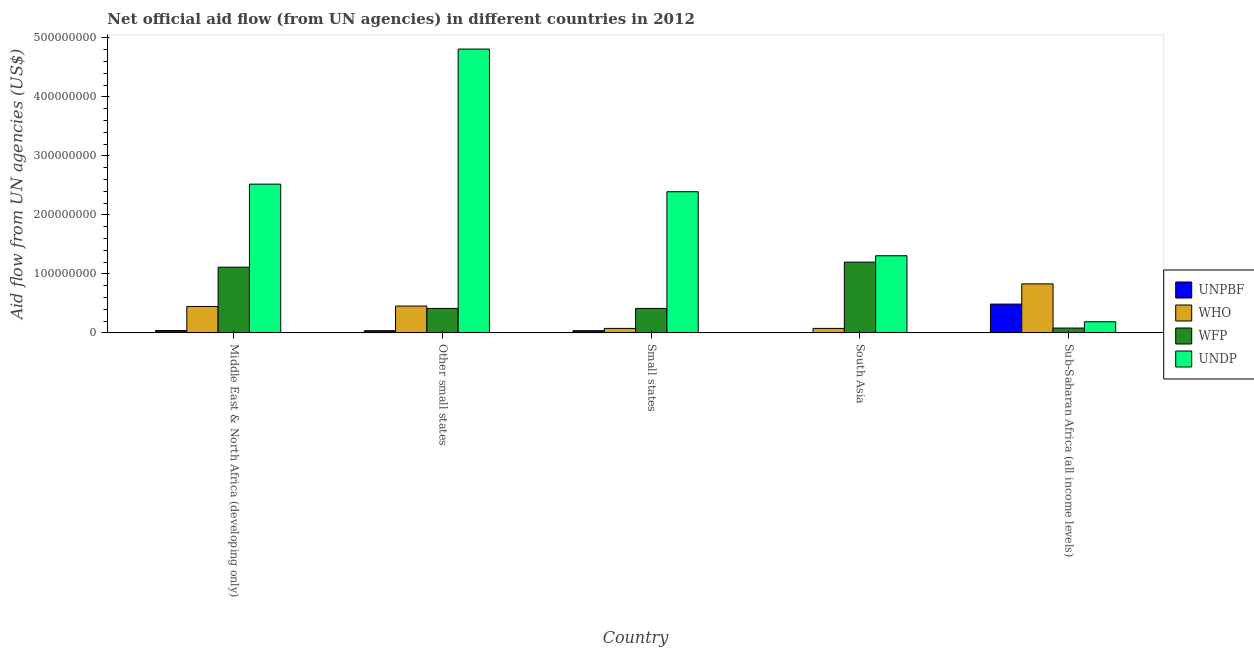How many different coloured bars are there?
Keep it short and to the point. 4. What is the label of the 2nd group of bars from the left?
Your answer should be compact. Other small states. What is the amount of aid given by unpbf in South Asia?
Ensure brevity in your answer.  2.70e+05. Across all countries, what is the maximum amount of aid given by unpbf?
Make the answer very short. 4.89e+07. Across all countries, what is the minimum amount of aid given by unpbf?
Your response must be concise. 2.70e+05. In which country was the amount of aid given by undp maximum?
Give a very brief answer. Other small states. In which country was the amount of aid given by undp minimum?
Your answer should be compact. Sub-Saharan Africa (all income levels). What is the total amount of aid given by who in the graph?
Your answer should be compact. 1.89e+08. What is the difference between the amount of aid given by unpbf in Middle East & North Africa (developing only) and that in Sub-Saharan Africa (all income levels)?
Provide a short and direct response. -4.48e+07. What is the difference between the amount of aid given by wfp in Sub-Saharan Africa (all income levels) and the amount of aid given by unpbf in Small states?
Your answer should be compact. 4.46e+06. What is the average amount of aid given by wfp per country?
Your answer should be compact. 6.46e+07. What is the difference between the amount of aid given by undp and amount of aid given by wfp in Other small states?
Your answer should be compact. 4.40e+08. In how many countries, is the amount of aid given by wfp greater than 320000000 US$?
Offer a terse response. 0. What is the ratio of the amount of aid given by who in Other small states to that in Sub-Saharan Africa (all income levels)?
Provide a succinct answer. 0.55. Is the amount of aid given by undp in Small states less than that in Sub-Saharan Africa (all income levels)?
Provide a short and direct response. No. What is the difference between the highest and the second highest amount of aid given by unpbf?
Offer a terse response. 4.48e+07. What is the difference between the highest and the lowest amount of aid given by unpbf?
Provide a short and direct response. 4.86e+07. In how many countries, is the amount of aid given by unpbf greater than the average amount of aid given by unpbf taken over all countries?
Provide a succinct answer. 1. Is the sum of the amount of aid given by who in Small states and South Asia greater than the maximum amount of aid given by wfp across all countries?
Your response must be concise. No. What does the 2nd bar from the left in Other small states represents?
Give a very brief answer. WHO. What does the 2nd bar from the right in Sub-Saharan Africa (all income levels) represents?
Keep it short and to the point. WFP. Is it the case that in every country, the sum of the amount of aid given by unpbf and amount of aid given by who is greater than the amount of aid given by wfp?
Provide a succinct answer. No. Are all the bars in the graph horizontal?
Your answer should be very brief. No. How many countries are there in the graph?
Offer a very short reply. 5. Does the graph contain any zero values?
Your answer should be compact. No. Does the graph contain grids?
Give a very brief answer. No. How many legend labels are there?
Ensure brevity in your answer.  4. What is the title of the graph?
Provide a short and direct response. Net official aid flow (from UN agencies) in different countries in 2012. Does "UNDP" appear as one of the legend labels in the graph?
Offer a very short reply. Yes. What is the label or title of the Y-axis?
Offer a very short reply. Aid flow from UN agencies (US$). What is the Aid flow from UN agencies (US$) of UNPBF in Middle East & North Africa (developing only)?
Give a very brief answer. 4.11e+06. What is the Aid flow from UN agencies (US$) of WHO in Middle East & North Africa (developing only)?
Your answer should be very brief. 4.49e+07. What is the Aid flow from UN agencies (US$) in WFP in Middle East & North Africa (developing only)?
Your answer should be compact. 1.11e+08. What is the Aid flow from UN agencies (US$) of UNDP in Middle East & North Africa (developing only)?
Provide a short and direct response. 2.52e+08. What is the Aid flow from UN agencies (US$) of UNPBF in Other small states?
Give a very brief answer. 3.82e+06. What is the Aid flow from UN agencies (US$) of WHO in Other small states?
Provide a succinct answer. 4.56e+07. What is the Aid flow from UN agencies (US$) of WFP in Other small states?
Make the answer very short. 4.16e+07. What is the Aid flow from UN agencies (US$) in UNDP in Other small states?
Your answer should be compact. 4.81e+08. What is the Aid flow from UN agencies (US$) of UNPBF in Small states?
Offer a very short reply. 3.82e+06. What is the Aid flow from UN agencies (US$) in WHO in Small states?
Your response must be concise. 7.70e+06. What is the Aid flow from UN agencies (US$) in WFP in Small states?
Keep it short and to the point. 4.16e+07. What is the Aid flow from UN agencies (US$) of UNDP in Small states?
Provide a short and direct response. 2.39e+08. What is the Aid flow from UN agencies (US$) in UNPBF in South Asia?
Your response must be concise. 2.70e+05. What is the Aid flow from UN agencies (US$) in WHO in South Asia?
Make the answer very short. 7.70e+06. What is the Aid flow from UN agencies (US$) in WFP in South Asia?
Your answer should be very brief. 1.20e+08. What is the Aid flow from UN agencies (US$) of UNDP in South Asia?
Your answer should be very brief. 1.31e+08. What is the Aid flow from UN agencies (US$) in UNPBF in Sub-Saharan Africa (all income levels)?
Your response must be concise. 4.89e+07. What is the Aid flow from UN agencies (US$) in WHO in Sub-Saharan Africa (all income levels)?
Keep it short and to the point. 8.32e+07. What is the Aid flow from UN agencies (US$) in WFP in Sub-Saharan Africa (all income levels)?
Your answer should be very brief. 8.28e+06. What is the Aid flow from UN agencies (US$) of UNDP in Sub-Saharan Africa (all income levels)?
Ensure brevity in your answer.  1.90e+07. Across all countries, what is the maximum Aid flow from UN agencies (US$) of UNPBF?
Keep it short and to the point. 4.89e+07. Across all countries, what is the maximum Aid flow from UN agencies (US$) of WHO?
Keep it short and to the point. 8.32e+07. Across all countries, what is the maximum Aid flow from UN agencies (US$) in WFP?
Give a very brief answer. 1.20e+08. Across all countries, what is the maximum Aid flow from UN agencies (US$) of UNDP?
Provide a short and direct response. 4.81e+08. Across all countries, what is the minimum Aid flow from UN agencies (US$) of UNPBF?
Make the answer very short. 2.70e+05. Across all countries, what is the minimum Aid flow from UN agencies (US$) in WHO?
Your answer should be very brief. 7.70e+06. Across all countries, what is the minimum Aid flow from UN agencies (US$) of WFP?
Provide a short and direct response. 8.28e+06. Across all countries, what is the minimum Aid flow from UN agencies (US$) of UNDP?
Offer a very short reply. 1.90e+07. What is the total Aid flow from UN agencies (US$) of UNPBF in the graph?
Keep it short and to the point. 6.09e+07. What is the total Aid flow from UN agencies (US$) in WHO in the graph?
Offer a terse response. 1.89e+08. What is the total Aid flow from UN agencies (US$) in WFP in the graph?
Keep it short and to the point. 3.23e+08. What is the total Aid flow from UN agencies (US$) in UNDP in the graph?
Offer a terse response. 1.12e+09. What is the difference between the Aid flow from UN agencies (US$) of WHO in Middle East & North Africa (developing only) and that in Other small states?
Keep it short and to the point. -7.30e+05. What is the difference between the Aid flow from UN agencies (US$) in WFP in Middle East & North Africa (developing only) and that in Other small states?
Your response must be concise. 6.99e+07. What is the difference between the Aid flow from UN agencies (US$) in UNDP in Middle East & North Africa (developing only) and that in Other small states?
Offer a terse response. -2.29e+08. What is the difference between the Aid flow from UN agencies (US$) in UNPBF in Middle East & North Africa (developing only) and that in Small states?
Provide a short and direct response. 2.90e+05. What is the difference between the Aid flow from UN agencies (US$) in WHO in Middle East & North Africa (developing only) and that in Small states?
Provide a short and direct response. 3.72e+07. What is the difference between the Aid flow from UN agencies (US$) in WFP in Middle East & North Africa (developing only) and that in Small states?
Give a very brief answer. 6.99e+07. What is the difference between the Aid flow from UN agencies (US$) of UNDP in Middle East & North Africa (developing only) and that in Small states?
Provide a short and direct response. 1.29e+07. What is the difference between the Aid flow from UN agencies (US$) of UNPBF in Middle East & North Africa (developing only) and that in South Asia?
Your response must be concise. 3.84e+06. What is the difference between the Aid flow from UN agencies (US$) in WHO in Middle East & North Africa (developing only) and that in South Asia?
Make the answer very short. 3.72e+07. What is the difference between the Aid flow from UN agencies (US$) of WFP in Middle East & North Africa (developing only) and that in South Asia?
Keep it short and to the point. -8.57e+06. What is the difference between the Aid flow from UN agencies (US$) in UNDP in Middle East & North Africa (developing only) and that in South Asia?
Offer a very short reply. 1.21e+08. What is the difference between the Aid flow from UN agencies (US$) of UNPBF in Middle East & North Africa (developing only) and that in Sub-Saharan Africa (all income levels)?
Your response must be concise. -4.48e+07. What is the difference between the Aid flow from UN agencies (US$) in WHO in Middle East & North Africa (developing only) and that in Sub-Saharan Africa (all income levels)?
Your response must be concise. -3.83e+07. What is the difference between the Aid flow from UN agencies (US$) in WFP in Middle East & North Africa (developing only) and that in Sub-Saharan Africa (all income levels)?
Your response must be concise. 1.03e+08. What is the difference between the Aid flow from UN agencies (US$) in UNDP in Middle East & North Africa (developing only) and that in Sub-Saharan Africa (all income levels)?
Give a very brief answer. 2.33e+08. What is the difference between the Aid flow from UN agencies (US$) of UNPBF in Other small states and that in Small states?
Provide a succinct answer. 0. What is the difference between the Aid flow from UN agencies (US$) in WHO in Other small states and that in Small states?
Your response must be concise. 3.79e+07. What is the difference between the Aid flow from UN agencies (US$) in WFP in Other small states and that in Small states?
Ensure brevity in your answer.  0. What is the difference between the Aid flow from UN agencies (US$) of UNDP in Other small states and that in Small states?
Your response must be concise. 2.42e+08. What is the difference between the Aid flow from UN agencies (US$) of UNPBF in Other small states and that in South Asia?
Offer a terse response. 3.55e+06. What is the difference between the Aid flow from UN agencies (US$) of WHO in Other small states and that in South Asia?
Provide a short and direct response. 3.79e+07. What is the difference between the Aid flow from UN agencies (US$) of WFP in Other small states and that in South Asia?
Provide a short and direct response. -7.85e+07. What is the difference between the Aid flow from UN agencies (US$) in UNDP in Other small states and that in South Asia?
Provide a succinct answer. 3.50e+08. What is the difference between the Aid flow from UN agencies (US$) of UNPBF in Other small states and that in Sub-Saharan Africa (all income levels)?
Provide a short and direct response. -4.51e+07. What is the difference between the Aid flow from UN agencies (US$) of WHO in Other small states and that in Sub-Saharan Africa (all income levels)?
Your answer should be compact. -3.76e+07. What is the difference between the Aid flow from UN agencies (US$) of WFP in Other small states and that in Sub-Saharan Africa (all income levels)?
Your answer should be compact. 3.33e+07. What is the difference between the Aid flow from UN agencies (US$) in UNDP in Other small states and that in Sub-Saharan Africa (all income levels)?
Your response must be concise. 4.62e+08. What is the difference between the Aid flow from UN agencies (US$) of UNPBF in Small states and that in South Asia?
Make the answer very short. 3.55e+06. What is the difference between the Aid flow from UN agencies (US$) in WFP in Small states and that in South Asia?
Offer a terse response. -7.85e+07. What is the difference between the Aid flow from UN agencies (US$) of UNDP in Small states and that in South Asia?
Provide a short and direct response. 1.09e+08. What is the difference between the Aid flow from UN agencies (US$) of UNPBF in Small states and that in Sub-Saharan Africa (all income levels)?
Your answer should be very brief. -4.51e+07. What is the difference between the Aid flow from UN agencies (US$) in WHO in Small states and that in Sub-Saharan Africa (all income levels)?
Provide a short and direct response. -7.55e+07. What is the difference between the Aid flow from UN agencies (US$) in WFP in Small states and that in Sub-Saharan Africa (all income levels)?
Provide a short and direct response. 3.33e+07. What is the difference between the Aid flow from UN agencies (US$) of UNDP in Small states and that in Sub-Saharan Africa (all income levels)?
Give a very brief answer. 2.20e+08. What is the difference between the Aid flow from UN agencies (US$) of UNPBF in South Asia and that in Sub-Saharan Africa (all income levels)?
Make the answer very short. -4.86e+07. What is the difference between the Aid flow from UN agencies (US$) in WHO in South Asia and that in Sub-Saharan Africa (all income levels)?
Your response must be concise. -7.55e+07. What is the difference between the Aid flow from UN agencies (US$) in WFP in South Asia and that in Sub-Saharan Africa (all income levels)?
Your answer should be very brief. 1.12e+08. What is the difference between the Aid flow from UN agencies (US$) of UNDP in South Asia and that in Sub-Saharan Africa (all income levels)?
Your answer should be compact. 1.12e+08. What is the difference between the Aid flow from UN agencies (US$) in UNPBF in Middle East & North Africa (developing only) and the Aid flow from UN agencies (US$) in WHO in Other small states?
Your answer should be very brief. -4.15e+07. What is the difference between the Aid flow from UN agencies (US$) in UNPBF in Middle East & North Africa (developing only) and the Aid flow from UN agencies (US$) in WFP in Other small states?
Provide a short and direct response. -3.75e+07. What is the difference between the Aid flow from UN agencies (US$) in UNPBF in Middle East & North Africa (developing only) and the Aid flow from UN agencies (US$) in UNDP in Other small states?
Give a very brief answer. -4.77e+08. What is the difference between the Aid flow from UN agencies (US$) of WHO in Middle East & North Africa (developing only) and the Aid flow from UN agencies (US$) of WFP in Other small states?
Give a very brief answer. 3.30e+06. What is the difference between the Aid flow from UN agencies (US$) in WHO in Middle East & North Africa (developing only) and the Aid flow from UN agencies (US$) in UNDP in Other small states?
Make the answer very short. -4.36e+08. What is the difference between the Aid flow from UN agencies (US$) in WFP in Middle East & North Africa (developing only) and the Aid flow from UN agencies (US$) in UNDP in Other small states?
Your answer should be compact. -3.70e+08. What is the difference between the Aid flow from UN agencies (US$) in UNPBF in Middle East & North Africa (developing only) and the Aid flow from UN agencies (US$) in WHO in Small states?
Your response must be concise. -3.59e+06. What is the difference between the Aid flow from UN agencies (US$) of UNPBF in Middle East & North Africa (developing only) and the Aid flow from UN agencies (US$) of WFP in Small states?
Your response must be concise. -3.75e+07. What is the difference between the Aid flow from UN agencies (US$) of UNPBF in Middle East & North Africa (developing only) and the Aid flow from UN agencies (US$) of UNDP in Small states?
Keep it short and to the point. -2.35e+08. What is the difference between the Aid flow from UN agencies (US$) of WHO in Middle East & North Africa (developing only) and the Aid flow from UN agencies (US$) of WFP in Small states?
Offer a terse response. 3.30e+06. What is the difference between the Aid flow from UN agencies (US$) of WHO in Middle East & North Africa (developing only) and the Aid flow from UN agencies (US$) of UNDP in Small states?
Your response must be concise. -1.94e+08. What is the difference between the Aid flow from UN agencies (US$) in WFP in Middle East & North Africa (developing only) and the Aid flow from UN agencies (US$) in UNDP in Small states?
Provide a succinct answer. -1.28e+08. What is the difference between the Aid flow from UN agencies (US$) of UNPBF in Middle East & North Africa (developing only) and the Aid flow from UN agencies (US$) of WHO in South Asia?
Your answer should be very brief. -3.59e+06. What is the difference between the Aid flow from UN agencies (US$) of UNPBF in Middle East & North Africa (developing only) and the Aid flow from UN agencies (US$) of WFP in South Asia?
Make the answer very short. -1.16e+08. What is the difference between the Aid flow from UN agencies (US$) of UNPBF in Middle East & North Africa (developing only) and the Aid flow from UN agencies (US$) of UNDP in South Asia?
Give a very brief answer. -1.27e+08. What is the difference between the Aid flow from UN agencies (US$) of WHO in Middle East & North Africa (developing only) and the Aid flow from UN agencies (US$) of WFP in South Asia?
Give a very brief answer. -7.52e+07. What is the difference between the Aid flow from UN agencies (US$) of WHO in Middle East & North Africa (developing only) and the Aid flow from UN agencies (US$) of UNDP in South Asia?
Your answer should be compact. -8.60e+07. What is the difference between the Aid flow from UN agencies (US$) of WFP in Middle East & North Africa (developing only) and the Aid flow from UN agencies (US$) of UNDP in South Asia?
Provide a short and direct response. -1.94e+07. What is the difference between the Aid flow from UN agencies (US$) of UNPBF in Middle East & North Africa (developing only) and the Aid flow from UN agencies (US$) of WHO in Sub-Saharan Africa (all income levels)?
Make the answer very short. -7.91e+07. What is the difference between the Aid flow from UN agencies (US$) of UNPBF in Middle East & North Africa (developing only) and the Aid flow from UN agencies (US$) of WFP in Sub-Saharan Africa (all income levels)?
Offer a terse response. -4.17e+06. What is the difference between the Aid flow from UN agencies (US$) in UNPBF in Middle East & North Africa (developing only) and the Aid flow from UN agencies (US$) in UNDP in Sub-Saharan Africa (all income levels)?
Ensure brevity in your answer.  -1.48e+07. What is the difference between the Aid flow from UN agencies (US$) of WHO in Middle East & North Africa (developing only) and the Aid flow from UN agencies (US$) of WFP in Sub-Saharan Africa (all income levels)?
Offer a very short reply. 3.66e+07. What is the difference between the Aid flow from UN agencies (US$) in WHO in Middle East & North Africa (developing only) and the Aid flow from UN agencies (US$) in UNDP in Sub-Saharan Africa (all income levels)?
Ensure brevity in your answer.  2.59e+07. What is the difference between the Aid flow from UN agencies (US$) of WFP in Middle East & North Africa (developing only) and the Aid flow from UN agencies (US$) of UNDP in Sub-Saharan Africa (all income levels)?
Your response must be concise. 9.25e+07. What is the difference between the Aid flow from UN agencies (US$) of UNPBF in Other small states and the Aid flow from UN agencies (US$) of WHO in Small states?
Your response must be concise. -3.88e+06. What is the difference between the Aid flow from UN agencies (US$) in UNPBF in Other small states and the Aid flow from UN agencies (US$) in WFP in Small states?
Your answer should be very brief. -3.78e+07. What is the difference between the Aid flow from UN agencies (US$) in UNPBF in Other small states and the Aid flow from UN agencies (US$) in UNDP in Small states?
Offer a very short reply. -2.36e+08. What is the difference between the Aid flow from UN agencies (US$) in WHO in Other small states and the Aid flow from UN agencies (US$) in WFP in Small states?
Offer a terse response. 4.03e+06. What is the difference between the Aid flow from UN agencies (US$) in WHO in Other small states and the Aid flow from UN agencies (US$) in UNDP in Small states?
Make the answer very short. -1.94e+08. What is the difference between the Aid flow from UN agencies (US$) of WFP in Other small states and the Aid flow from UN agencies (US$) of UNDP in Small states?
Offer a very short reply. -1.98e+08. What is the difference between the Aid flow from UN agencies (US$) of UNPBF in Other small states and the Aid flow from UN agencies (US$) of WHO in South Asia?
Offer a very short reply. -3.88e+06. What is the difference between the Aid flow from UN agencies (US$) of UNPBF in Other small states and the Aid flow from UN agencies (US$) of WFP in South Asia?
Your answer should be compact. -1.16e+08. What is the difference between the Aid flow from UN agencies (US$) of UNPBF in Other small states and the Aid flow from UN agencies (US$) of UNDP in South Asia?
Provide a succinct answer. -1.27e+08. What is the difference between the Aid flow from UN agencies (US$) in WHO in Other small states and the Aid flow from UN agencies (US$) in WFP in South Asia?
Provide a short and direct response. -7.44e+07. What is the difference between the Aid flow from UN agencies (US$) in WHO in Other small states and the Aid flow from UN agencies (US$) in UNDP in South Asia?
Provide a short and direct response. -8.52e+07. What is the difference between the Aid flow from UN agencies (US$) in WFP in Other small states and the Aid flow from UN agencies (US$) in UNDP in South Asia?
Your response must be concise. -8.93e+07. What is the difference between the Aid flow from UN agencies (US$) in UNPBF in Other small states and the Aid flow from UN agencies (US$) in WHO in Sub-Saharan Africa (all income levels)?
Give a very brief answer. -7.94e+07. What is the difference between the Aid flow from UN agencies (US$) of UNPBF in Other small states and the Aid flow from UN agencies (US$) of WFP in Sub-Saharan Africa (all income levels)?
Provide a short and direct response. -4.46e+06. What is the difference between the Aid flow from UN agencies (US$) in UNPBF in Other small states and the Aid flow from UN agencies (US$) in UNDP in Sub-Saharan Africa (all income levels)?
Provide a succinct answer. -1.51e+07. What is the difference between the Aid flow from UN agencies (US$) of WHO in Other small states and the Aid flow from UN agencies (US$) of WFP in Sub-Saharan Africa (all income levels)?
Ensure brevity in your answer.  3.73e+07. What is the difference between the Aid flow from UN agencies (US$) of WHO in Other small states and the Aid flow from UN agencies (US$) of UNDP in Sub-Saharan Africa (all income levels)?
Offer a very short reply. 2.66e+07. What is the difference between the Aid flow from UN agencies (US$) in WFP in Other small states and the Aid flow from UN agencies (US$) in UNDP in Sub-Saharan Africa (all income levels)?
Offer a terse response. 2.26e+07. What is the difference between the Aid flow from UN agencies (US$) in UNPBF in Small states and the Aid flow from UN agencies (US$) in WHO in South Asia?
Give a very brief answer. -3.88e+06. What is the difference between the Aid flow from UN agencies (US$) in UNPBF in Small states and the Aid flow from UN agencies (US$) in WFP in South Asia?
Provide a short and direct response. -1.16e+08. What is the difference between the Aid flow from UN agencies (US$) in UNPBF in Small states and the Aid flow from UN agencies (US$) in UNDP in South Asia?
Your answer should be compact. -1.27e+08. What is the difference between the Aid flow from UN agencies (US$) of WHO in Small states and the Aid flow from UN agencies (US$) of WFP in South Asia?
Your response must be concise. -1.12e+08. What is the difference between the Aid flow from UN agencies (US$) in WHO in Small states and the Aid flow from UN agencies (US$) in UNDP in South Asia?
Give a very brief answer. -1.23e+08. What is the difference between the Aid flow from UN agencies (US$) of WFP in Small states and the Aid flow from UN agencies (US$) of UNDP in South Asia?
Provide a short and direct response. -8.93e+07. What is the difference between the Aid flow from UN agencies (US$) in UNPBF in Small states and the Aid flow from UN agencies (US$) in WHO in Sub-Saharan Africa (all income levels)?
Your response must be concise. -7.94e+07. What is the difference between the Aid flow from UN agencies (US$) in UNPBF in Small states and the Aid flow from UN agencies (US$) in WFP in Sub-Saharan Africa (all income levels)?
Your response must be concise. -4.46e+06. What is the difference between the Aid flow from UN agencies (US$) of UNPBF in Small states and the Aid flow from UN agencies (US$) of UNDP in Sub-Saharan Africa (all income levels)?
Make the answer very short. -1.51e+07. What is the difference between the Aid flow from UN agencies (US$) of WHO in Small states and the Aid flow from UN agencies (US$) of WFP in Sub-Saharan Africa (all income levels)?
Provide a succinct answer. -5.80e+05. What is the difference between the Aid flow from UN agencies (US$) of WHO in Small states and the Aid flow from UN agencies (US$) of UNDP in Sub-Saharan Africa (all income levels)?
Provide a short and direct response. -1.13e+07. What is the difference between the Aid flow from UN agencies (US$) in WFP in Small states and the Aid flow from UN agencies (US$) in UNDP in Sub-Saharan Africa (all income levels)?
Provide a succinct answer. 2.26e+07. What is the difference between the Aid flow from UN agencies (US$) in UNPBF in South Asia and the Aid flow from UN agencies (US$) in WHO in Sub-Saharan Africa (all income levels)?
Your answer should be very brief. -8.29e+07. What is the difference between the Aid flow from UN agencies (US$) in UNPBF in South Asia and the Aid flow from UN agencies (US$) in WFP in Sub-Saharan Africa (all income levels)?
Make the answer very short. -8.01e+06. What is the difference between the Aid flow from UN agencies (US$) in UNPBF in South Asia and the Aid flow from UN agencies (US$) in UNDP in Sub-Saharan Africa (all income levels)?
Offer a very short reply. -1.87e+07. What is the difference between the Aid flow from UN agencies (US$) in WHO in South Asia and the Aid flow from UN agencies (US$) in WFP in Sub-Saharan Africa (all income levels)?
Make the answer very short. -5.80e+05. What is the difference between the Aid flow from UN agencies (US$) of WHO in South Asia and the Aid flow from UN agencies (US$) of UNDP in Sub-Saharan Africa (all income levels)?
Keep it short and to the point. -1.13e+07. What is the difference between the Aid flow from UN agencies (US$) in WFP in South Asia and the Aid flow from UN agencies (US$) in UNDP in Sub-Saharan Africa (all income levels)?
Keep it short and to the point. 1.01e+08. What is the average Aid flow from UN agencies (US$) of UNPBF per country?
Provide a succinct answer. 1.22e+07. What is the average Aid flow from UN agencies (US$) in WHO per country?
Keep it short and to the point. 3.78e+07. What is the average Aid flow from UN agencies (US$) of WFP per country?
Make the answer very short. 6.46e+07. What is the average Aid flow from UN agencies (US$) in UNDP per country?
Give a very brief answer. 2.25e+08. What is the difference between the Aid flow from UN agencies (US$) of UNPBF and Aid flow from UN agencies (US$) of WHO in Middle East & North Africa (developing only)?
Offer a very short reply. -4.08e+07. What is the difference between the Aid flow from UN agencies (US$) in UNPBF and Aid flow from UN agencies (US$) in WFP in Middle East & North Africa (developing only)?
Provide a succinct answer. -1.07e+08. What is the difference between the Aid flow from UN agencies (US$) in UNPBF and Aid flow from UN agencies (US$) in UNDP in Middle East & North Africa (developing only)?
Provide a succinct answer. -2.48e+08. What is the difference between the Aid flow from UN agencies (US$) in WHO and Aid flow from UN agencies (US$) in WFP in Middle East & North Africa (developing only)?
Your answer should be compact. -6.66e+07. What is the difference between the Aid flow from UN agencies (US$) in WHO and Aid flow from UN agencies (US$) in UNDP in Middle East & North Africa (developing only)?
Your answer should be very brief. -2.07e+08. What is the difference between the Aid flow from UN agencies (US$) of WFP and Aid flow from UN agencies (US$) of UNDP in Middle East & North Africa (developing only)?
Provide a short and direct response. -1.41e+08. What is the difference between the Aid flow from UN agencies (US$) in UNPBF and Aid flow from UN agencies (US$) in WHO in Other small states?
Give a very brief answer. -4.18e+07. What is the difference between the Aid flow from UN agencies (US$) in UNPBF and Aid flow from UN agencies (US$) in WFP in Other small states?
Provide a succinct answer. -3.78e+07. What is the difference between the Aid flow from UN agencies (US$) in UNPBF and Aid flow from UN agencies (US$) in UNDP in Other small states?
Provide a short and direct response. -4.77e+08. What is the difference between the Aid flow from UN agencies (US$) of WHO and Aid flow from UN agencies (US$) of WFP in Other small states?
Your response must be concise. 4.03e+06. What is the difference between the Aid flow from UN agencies (US$) in WHO and Aid flow from UN agencies (US$) in UNDP in Other small states?
Offer a very short reply. -4.36e+08. What is the difference between the Aid flow from UN agencies (US$) in WFP and Aid flow from UN agencies (US$) in UNDP in Other small states?
Give a very brief answer. -4.40e+08. What is the difference between the Aid flow from UN agencies (US$) in UNPBF and Aid flow from UN agencies (US$) in WHO in Small states?
Your response must be concise. -3.88e+06. What is the difference between the Aid flow from UN agencies (US$) of UNPBF and Aid flow from UN agencies (US$) of WFP in Small states?
Give a very brief answer. -3.78e+07. What is the difference between the Aid flow from UN agencies (US$) in UNPBF and Aid flow from UN agencies (US$) in UNDP in Small states?
Offer a very short reply. -2.36e+08. What is the difference between the Aid flow from UN agencies (US$) of WHO and Aid flow from UN agencies (US$) of WFP in Small states?
Give a very brief answer. -3.39e+07. What is the difference between the Aid flow from UN agencies (US$) in WHO and Aid flow from UN agencies (US$) in UNDP in Small states?
Ensure brevity in your answer.  -2.32e+08. What is the difference between the Aid flow from UN agencies (US$) of WFP and Aid flow from UN agencies (US$) of UNDP in Small states?
Offer a terse response. -1.98e+08. What is the difference between the Aid flow from UN agencies (US$) in UNPBF and Aid flow from UN agencies (US$) in WHO in South Asia?
Ensure brevity in your answer.  -7.43e+06. What is the difference between the Aid flow from UN agencies (US$) of UNPBF and Aid flow from UN agencies (US$) of WFP in South Asia?
Offer a very short reply. -1.20e+08. What is the difference between the Aid flow from UN agencies (US$) in UNPBF and Aid flow from UN agencies (US$) in UNDP in South Asia?
Ensure brevity in your answer.  -1.31e+08. What is the difference between the Aid flow from UN agencies (US$) in WHO and Aid flow from UN agencies (US$) in WFP in South Asia?
Your answer should be very brief. -1.12e+08. What is the difference between the Aid flow from UN agencies (US$) of WHO and Aid flow from UN agencies (US$) of UNDP in South Asia?
Keep it short and to the point. -1.23e+08. What is the difference between the Aid flow from UN agencies (US$) in WFP and Aid flow from UN agencies (US$) in UNDP in South Asia?
Keep it short and to the point. -1.08e+07. What is the difference between the Aid flow from UN agencies (US$) of UNPBF and Aid flow from UN agencies (US$) of WHO in Sub-Saharan Africa (all income levels)?
Give a very brief answer. -3.43e+07. What is the difference between the Aid flow from UN agencies (US$) in UNPBF and Aid flow from UN agencies (US$) in WFP in Sub-Saharan Africa (all income levels)?
Provide a succinct answer. 4.06e+07. What is the difference between the Aid flow from UN agencies (US$) of UNPBF and Aid flow from UN agencies (US$) of UNDP in Sub-Saharan Africa (all income levels)?
Give a very brief answer. 3.00e+07. What is the difference between the Aid flow from UN agencies (US$) of WHO and Aid flow from UN agencies (US$) of WFP in Sub-Saharan Africa (all income levels)?
Ensure brevity in your answer.  7.49e+07. What is the difference between the Aid flow from UN agencies (US$) in WHO and Aid flow from UN agencies (US$) in UNDP in Sub-Saharan Africa (all income levels)?
Offer a very short reply. 6.42e+07. What is the difference between the Aid flow from UN agencies (US$) of WFP and Aid flow from UN agencies (US$) of UNDP in Sub-Saharan Africa (all income levels)?
Make the answer very short. -1.07e+07. What is the ratio of the Aid flow from UN agencies (US$) of UNPBF in Middle East & North Africa (developing only) to that in Other small states?
Provide a short and direct response. 1.08. What is the ratio of the Aid flow from UN agencies (US$) in WFP in Middle East & North Africa (developing only) to that in Other small states?
Ensure brevity in your answer.  2.68. What is the ratio of the Aid flow from UN agencies (US$) of UNDP in Middle East & North Africa (developing only) to that in Other small states?
Provide a succinct answer. 0.52. What is the ratio of the Aid flow from UN agencies (US$) of UNPBF in Middle East & North Africa (developing only) to that in Small states?
Give a very brief answer. 1.08. What is the ratio of the Aid flow from UN agencies (US$) in WHO in Middle East & North Africa (developing only) to that in Small states?
Keep it short and to the point. 5.83. What is the ratio of the Aid flow from UN agencies (US$) in WFP in Middle East & North Africa (developing only) to that in Small states?
Provide a short and direct response. 2.68. What is the ratio of the Aid flow from UN agencies (US$) of UNDP in Middle East & North Africa (developing only) to that in Small states?
Make the answer very short. 1.05. What is the ratio of the Aid flow from UN agencies (US$) in UNPBF in Middle East & North Africa (developing only) to that in South Asia?
Your answer should be very brief. 15.22. What is the ratio of the Aid flow from UN agencies (US$) of WHO in Middle East & North Africa (developing only) to that in South Asia?
Give a very brief answer. 5.83. What is the ratio of the Aid flow from UN agencies (US$) in UNDP in Middle East & North Africa (developing only) to that in South Asia?
Your response must be concise. 1.93. What is the ratio of the Aid flow from UN agencies (US$) in UNPBF in Middle East & North Africa (developing only) to that in Sub-Saharan Africa (all income levels)?
Your response must be concise. 0.08. What is the ratio of the Aid flow from UN agencies (US$) in WHO in Middle East & North Africa (developing only) to that in Sub-Saharan Africa (all income levels)?
Provide a short and direct response. 0.54. What is the ratio of the Aid flow from UN agencies (US$) of WFP in Middle East & North Africa (developing only) to that in Sub-Saharan Africa (all income levels)?
Offer a terse response. 13.46. What is the ratio of the Aid flow from UN agencies (US$) of UNDP in Middle East & North Africa (developing only) to that in Sub-Saharan Africa (all income levels)?
Give a very brief answer. 13.3. What is the ratio of the Aid flow from UN agencies (US$) of WHO in Other small states to that in Small states?
Your answer should be compact. 5.92. What is the ratio of the Aid flow from UN agencies (US$) of WFP in Other small states to that in Small states?
Provide a short and direct response. 1. What is the ratio of the Aid flow from UN agencies (US$) of UNDP in Other small states to that in Small states?
Offer a terse response. 2.01. What is the ratio of the Aid flow from UN agencies (US$) in UNPBF in Other small states to that in South Asia?
Make the answer very short. 14.15. What is the ratio of the Aid flow from UN agencies (US$) of WHO in Other small states to that in South Asia?
Your answer should be compact. 5.92. What is the ratio of the Aid flow from UN agencies (US$) in WFP in Other small states to that in South Asia?
Keep it short and to the point. 0.35. What is the ratio of the Aid flow from UN agencies (US$) of UNDP in Other small states to that in South Asia?
Your answer should be very brief. 3.68. What is the ratio of the Aid flow from UN agencies (US$) of UNPBF in Other small states to that in Sub-Saharan Africa (all income levels)?
Provide a succinct answer. 0.08. What is the ratio of the Aid flow from UN agencies (US$) in WHO in Other small states to that in Sub-Saharan Africa (all income levels)?
Make the answer very short. 0.55. What is the ratio of the Aid flow from UN agencies (US$) in WFP in Other small states to that in Sub-Saharan Africa (all income levels)?
Your answer should be very brief. 5.02. What is the ratio of the Aid flow from UN agencies (US$) of UNDP in Other small states to that in Sub-Saharan Africa (all income levels)?
Ensure brevity in your answer.  25.38. What is the ratio of the Aid flow from UN agencies (US$) in UNPBF in Small states to that in South Asia?
Offer a very short reply. 14.15. What is the ratio of the Aid flow from UN agencies (US$) in WHO in Small states to that in South Asia?
Provide a short and direct response. 1. What is the ratio of the Aid flow from UN agencies (US$) of WFP in Small states to that in South Asia?
Your response must be concise. 0.35. What is the ratio of the Aid flow from UN agencies (US$) of UNDP in Small states to that in South Asia?
Provide a succinct answer. 1.83. What is the ratio of the Aid flow from UN agencies (US$) of UNPBF in Small states to that in Sub-Saharan Africa (all income levels)?
Your answer should be compact. 0.08. What is the ratio of the Aid flow from UN agencies (US$) in WHO in Small states to that in Sub-Saharan Africa (all income levels)?
Provide a succinct answer. 0.09. What is the ratio of the Aid flow from UN agencies (US$) of WFP in Small states to that in Sub-Saharan Africa (all income levels)?
Offer a terse response. 5.02. What is the ratio of the Aid flow from UN agencies (US$) of UNDP in Small states to that in Sub-Saharan Africa (all income levels)?
Give a very brief answer. 12.62. What is the ratio of the Aid flow from UN agencies (US$) of UNPBF in South Asia to that in Sub-Saharan Africa (all income levels)?
Ensure brevity in your answer.  0.01. What is the ratio of the Aid flow from UN agencies (US$) in WHO in South Asia to that in Sub-Saharan Africa (all income levels)?
Your response must be concise. 0.09. What is the ratio of the Aid flow from UN agencies (US$) of WFP in South Asia to that in Sub-Saharan Africa (all income levels)?
Ensure brevity in your answer.  14.5. What is the ratio of the Aid flow from UN agencies (US$) of UNDP in South Asia to that in Sub-Saharan Africa (all income levels)?
Provide a short and direct response. 6.9. What is the difference between the highest and the second highest Aid flow from UN agencies (US$) in UNPBF?
Keep it short and to the point. 4.48e+07. What is the difference between the highest and the second highest Aid flow from UN agencies (US$) in WHO?
Offer a terse response. 3.76e+07. What is the difference between the highest and the second highest Aid flow from UN agencies (US$) of WFP?
Keep it short and to the point. 8.57e+06. What is the difference between the highest and the second highest Aid flow from UN agencies (US$) in UNDP?
Your answer should be compact. 2.29e+08. What is the difference between the highest and the lowest Aid flow from UN agencies (US$) of UNPBF?
Offer a terse response. 4.86e+07. What is the difference between the highest and the lowest Aid flow from UN agencies (US$) of WHO?
Give a very brief answer. 7.55e+07. What is the difference between the highest and the lowest Aid flow from UN agencies (US$) in WFP?
Offer a terse response. 1.12e+08. What is the difference between the highest and the lowest Aid flow from UN agencies (US$) of UNDP?
Your response must be concise. 4.62e+08. 